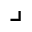<formula> <loc_0><loc_0><loc_500><loc_500>\lrcorner</formula> 